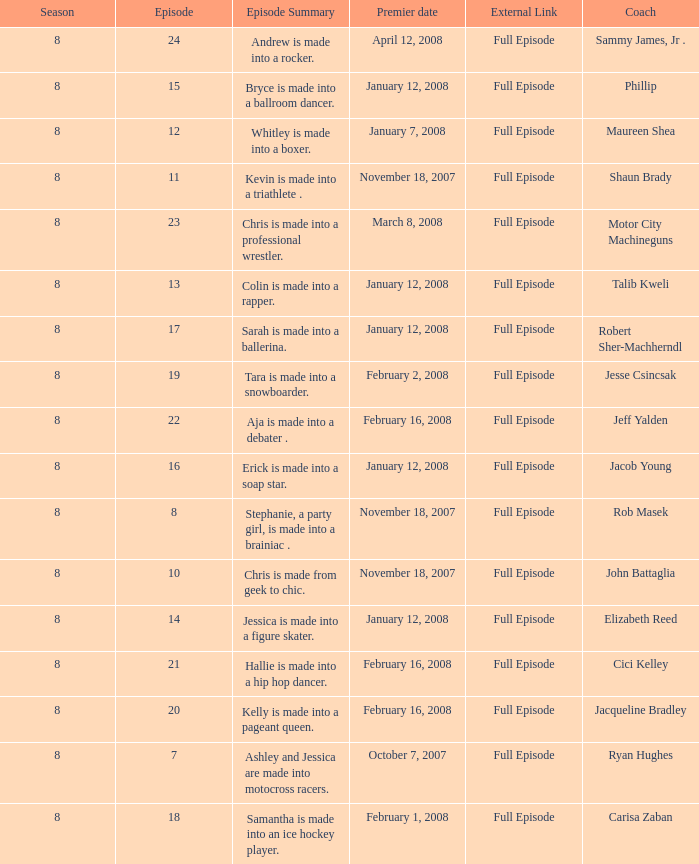Which Maximum episode premiered March 8, 2008? 23.0. Write the full table. {'header': ['Season', 'Episode', 'Episode Summary', 'Premier date', 'External Link', 'Coach'], 'rows': [['8', '24', 'Andrew is made into a rocker.', 'April 12, 2008', 'Full Episode', 'Sammy James, Jr .'], ['8', '15', 'Bryce is made into a ballroom dancer.', 'January 12, 2008', 'Full Episode', 'Phillip'], ['8', '12', 'Whitley is made into a boxer.', 'January 7, 2008', 'Full Episode', 'Maureen Shea'], ['8', '11', 'Kevin is made into a triathlete .', 'November 18, 2007', 'Full Episode', 'Shaun Brady'], ['8', '23', 'Chris is made into a professional wrestler.', 'March 8, 2008', 'Full Episode', 'Motor City Machineguns'], ['8', '13', 'Colin is made into a rapper.', 'January 12, 2008', 'Full Episode', 'Talib Kweli'], ['8', '17', 'Sarah is made into a ballerina.', 'January 12, 2008', 'Full Episode', 'Robert Sher-Machherndl'], ['8', '19', 'Tara is made into a snowboarder.', 'February 2, 2008', 'Full Episode', 'Jesse Csincsak'], ['8', '22', 'Aja is made into a debater .', 'February 16, 2008', 'Full Episode', 'Jeff Yalden'], ['8', '16', 'Erick is made into a soap star.', 'January 12, 2008', 'Full Episode', 'Jacob Young'], ['8', '8', 'Stephanie, a party girl, is made into a brainiac .', 'November 18, 2007', 'Full Episode', 'Rob Masek'], ['8', '10', 'Chris is made from geek to chic.', 'November 18, 2007', 'Full Episode', 'John Battaglia'], ['8', '14', 'Jessica is made into a figure skater.', 'January 12, 2008', 'Full Episode', 'Elizabeth Reed'], ['8', '21', 'Hallie is made into a hip hop dancer.', 'February 16, 2008', 'Full Episode', 'Cici Kelley'], ['8', '20', 'Kelly is made into a pageant queen.', 'February 16, 2008', 'Full Episode', 'Jacqueline Bradley'], ['8', '7', 'Ashley and Jessica are made into motocross racers.', 'October 7, 2007', 'Full Episode', 'Ryan Hughes'], ['8', '18', 'Samantha is made into an ice hockey player.', 'February 1, 2008', 'Full Episode', 'Carisa Zaban']]} 